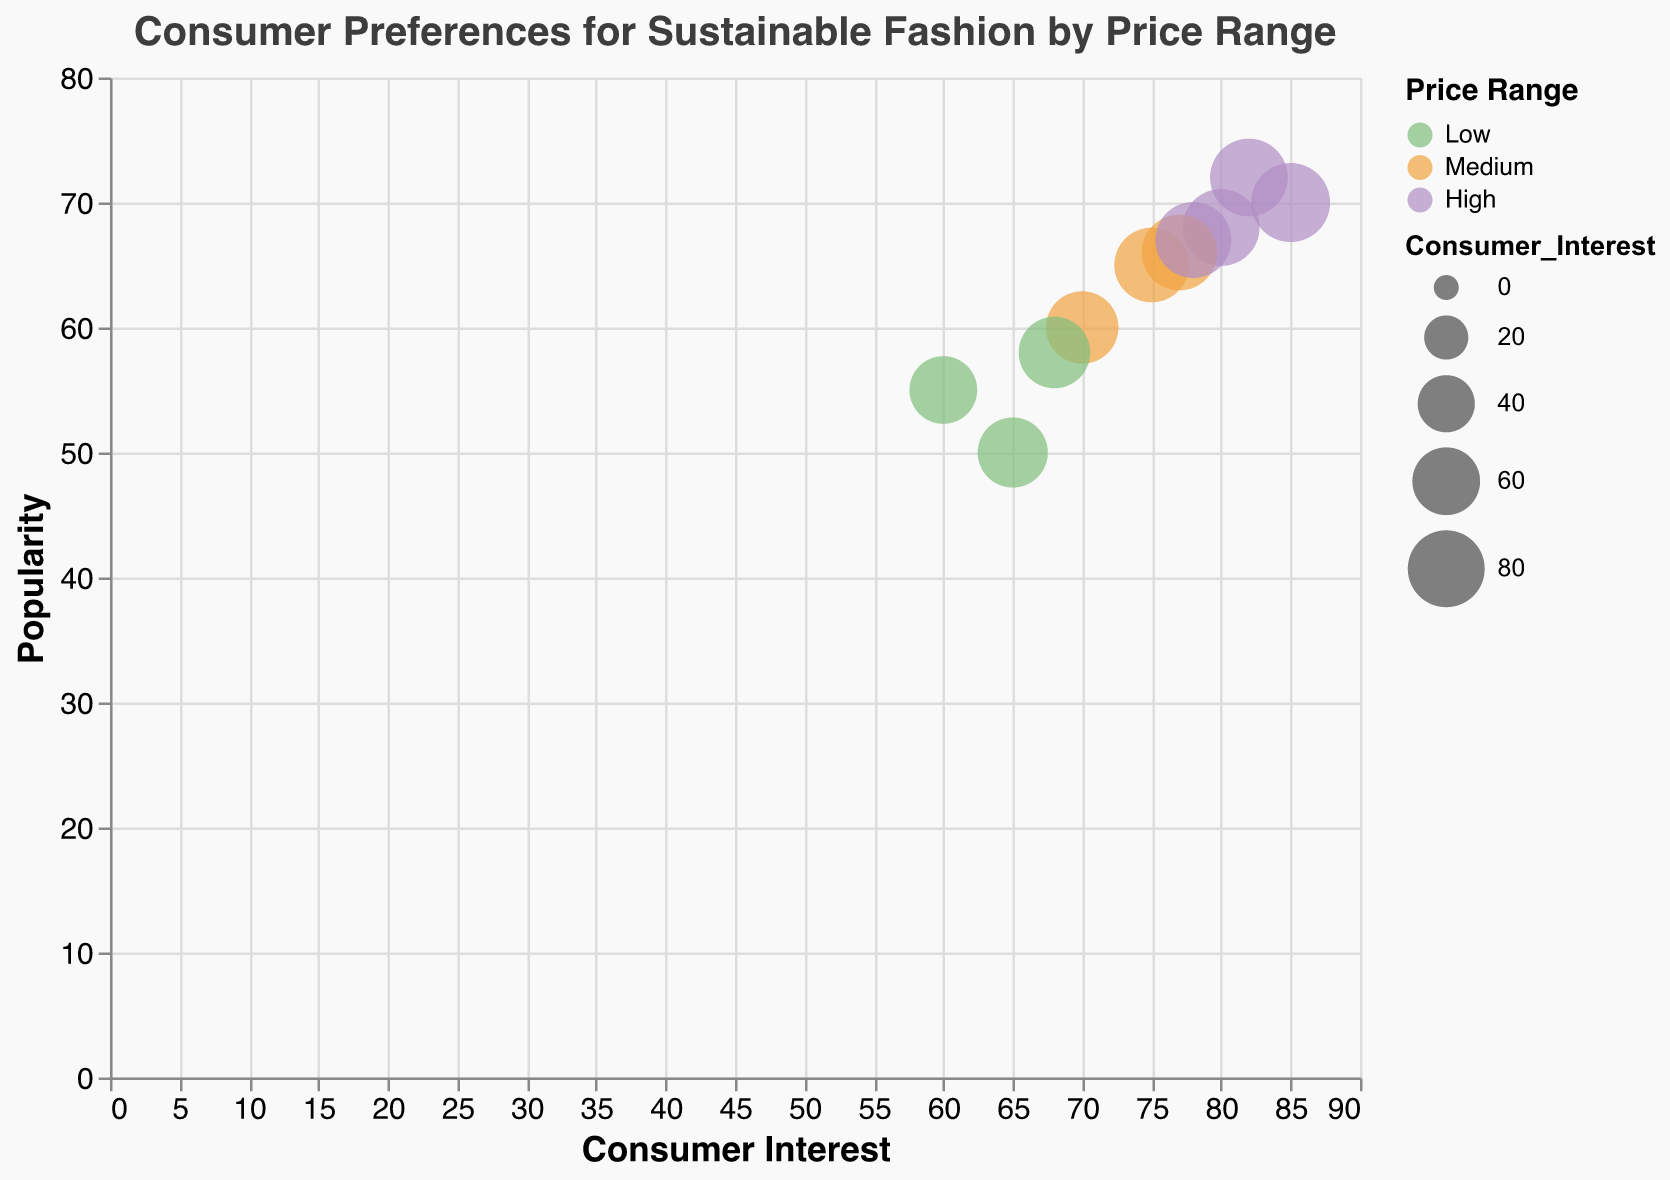How many brands have a high price range? There are four bubbles colored in the shade that represents high price range: Patagonia, Reformation, Stella McCartney, and Eileen Fisher.
Answer: 4 Which brand has the highest consumer interest? By looking at the x-axis, the brand with the bubble farthest to the right is Patagonia with a consumer interest of 85.
Answer: Patagonia What is the average popularity of brands in North America? In North America, the brands are: Patagonia (70), Everlane (65), Reformation (68), Levi's Wellthread (66), Pact (58), and Eileen Fisher (67). Summing these: 70 + 65 + 68 + 66 + 58 + 67 = 394. Dividing by the number of brands (6), the average popularity is 394/6.
Answer: 65.67 Which region has the highest average consumer interest? The North America data points are: Patagonia (85), Everlane (75), Reformation (80), Levi's Wellthread (77), Pact (68), and Eileen Fisher (78). Summing these: 85 + 75 + 80 + 77 + 68 + 78 = 463. The Europe data points are: H&M Conscious (60), Adidas x Parley (70), People Tree (65), Stella McCartney (82). Summing these: 60 + 70 + 65 + 82 = 277. 
For average: 
North America: 463/6 ≈ 77.17, 
Europe: 277/4 = 69.25. 
Comparing these, North America has higher average consumer interest.
Answer: North America Which brand in the medium price range has the highest popularity? Filter out brands in the medium price range: Everlane (65), Adidas x Parley (60), Levi's Wellthread (66). By comparing the popularity values, Levi's Wellthread has the highest with 66.
Answer: Levi's Wellthread What is the range of consumer interest (highest minus lowest) among all brands? The highest consumer interest is 85 (Patagonia) and the lowest is 60 (H&M Conscious). The range is 85 - 60.
Answer: 25 Are there more high price range brands in Europe or North America? The high price range brands in Europe are Stella McCartney. The high price range brands in North America are Patagonia, Reformation, Eileen Fisher.
Answer: North America Which brand has the largest bubble size depicted in the chart? The bubble size is proportional to consumer interest. The brand with the highest consumer interest, and hence largest bubble, is Patagonia with an interest of 85.
Answer: Patagonia How does the popularity of Reformation compare to Eileen Fisher? Reformation has a popularity of 68 while Eileen Fisher has a popularity of 67. Reformation's popularity is slightly higher.
Answer: Reformation has higher popularity 